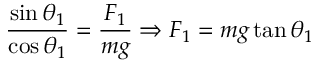<formula> <loc_0><loc_0><loc_500><loc_500>{ \frac { \sin \theta _ { 1 } } { \cos \theta _ { 1 } } } = { \frac { F _ { 1 } } { m g } } \Rightarrow F _ { 1 } = m g \tan \theta _ { 1 }</formula> 